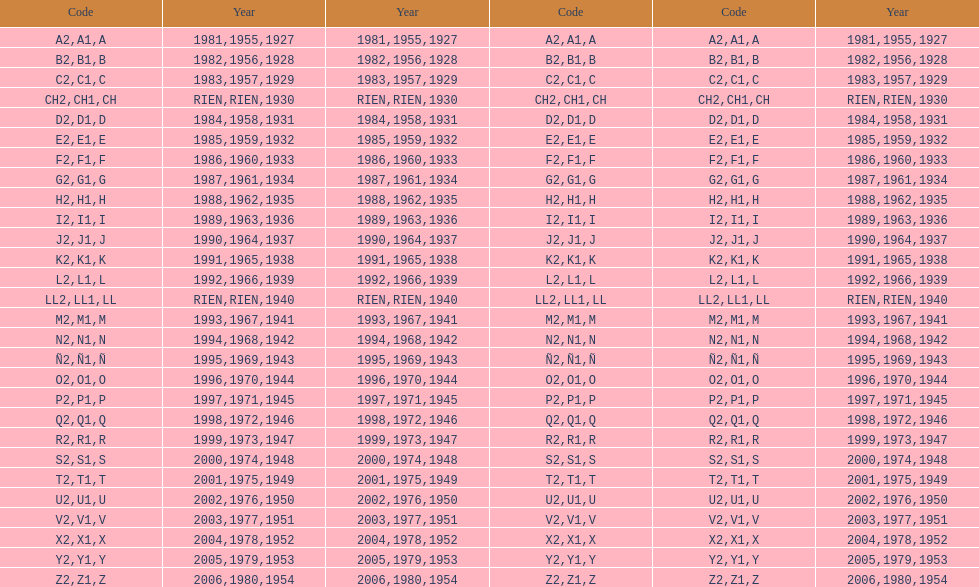Other than 1927 what year did the code start with a? 1955, 1981. 